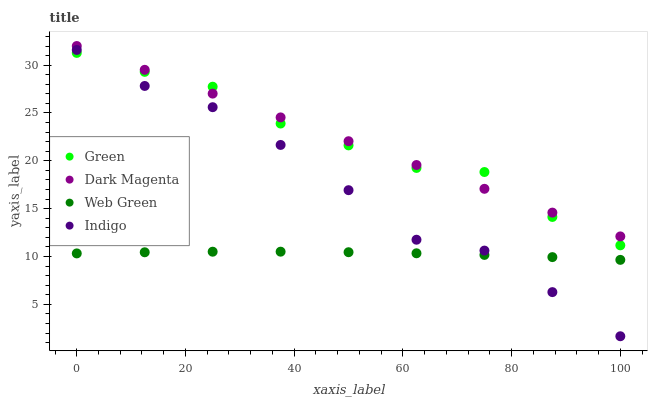Does Web Green have the minimum area under the curve?
Answer yes or no. Yes. Does Dark Magenta have the maximum area under the curve?
Answer yes or no. Yes. Does Green have the minimum area under the curve?
Answer yes or no. No. Does Green have the maximum area under the curve?
Answer yes or no. No. Is Dark Magenta the smoothest?
Answer yes or no. Yes. Is Green the roughest?
Answer yes or no. Yes. Is Green the smoothest?
Answer yes or no. No. Is Dark Magenta the roughest?
Answer yes or no. No. Does Indigo have the lowest value?
Answer yes or no. Yes. Does Green have the lowest value?
Answer yes or no. No. Does Dark Magenta have the highest value?
Answer yes or no. Yes. Does Green have the highest value?
Answer yes or no. No. Is Web Green less than Dark Magenta?
Answer yes or no. Yes. Is Dark Magenta greater than Indigo?
Answer yes or no. Yes. Does Dark Magenta intersect Green?
Answer yes or no. Yes. Is Dark Magenta less than Green?
Answer yes or no. No. Is Dark Magenta greater than Green?
Answer yes or no. No. Does Web Green intersect Dark Magenta?
Answer yes or no. No. 